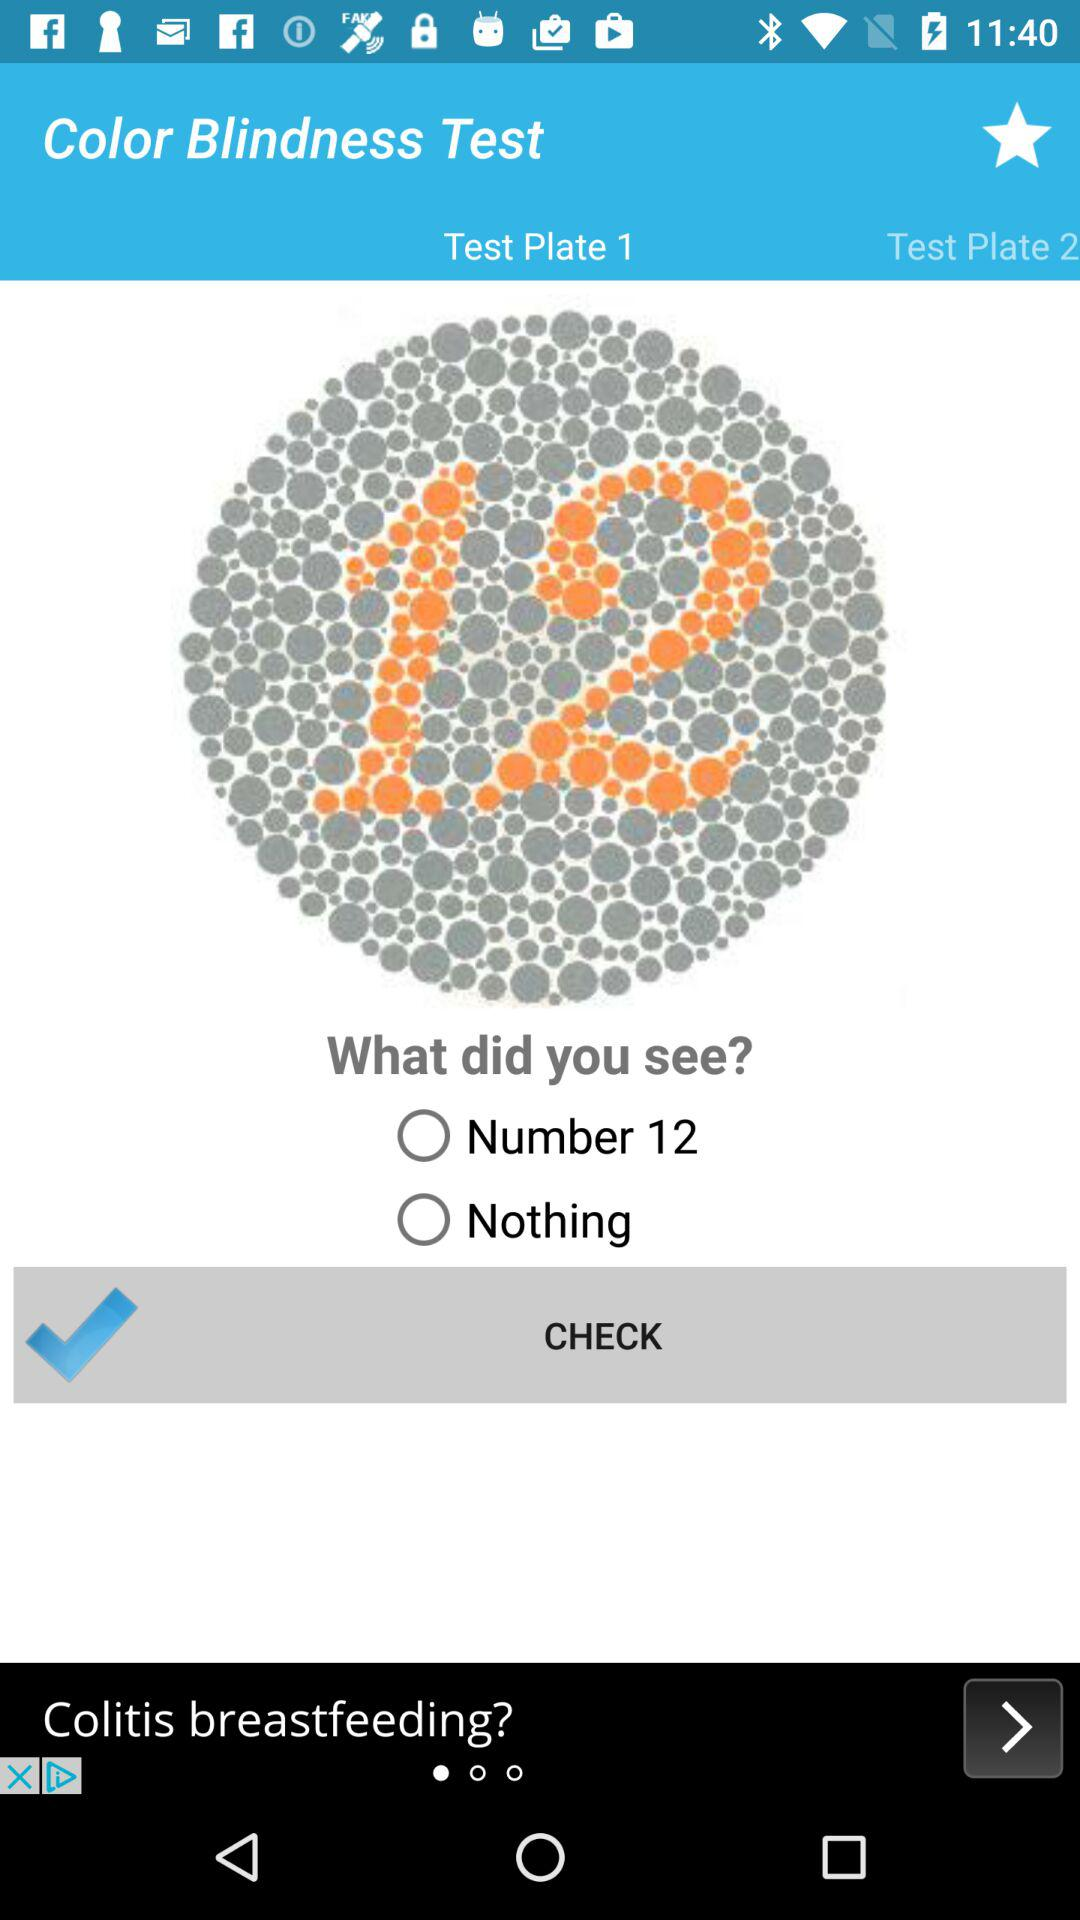What is the mentioned number on test plate 1? The mentioned number is 12. 